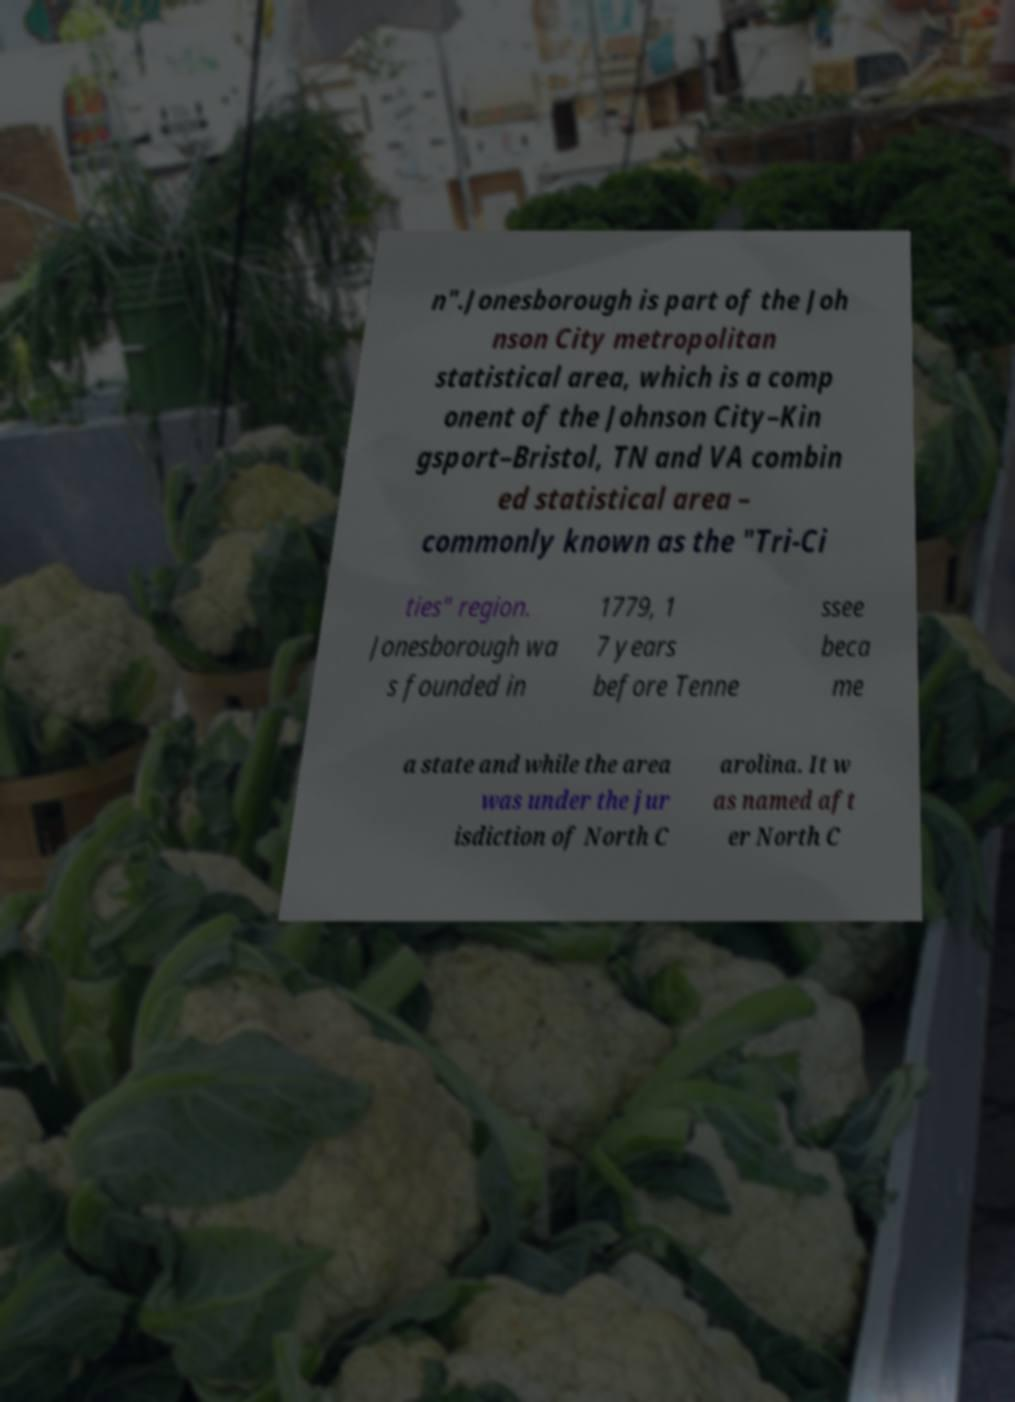I need the written content from this picture converted into text. Can you do that? n".Jonesborough is part of the Joh nson City metropolitan statistical area, which is a comp onent of the Johnson City–Kin gsport–Bristol, TN and VA combin ed statistical area – commonly known as the "Tri-Ci ties" region. Jonesborough wa s founded in 1779, 1 7 years before Tenne ssee beca me a state and while the area was under the jur isdiction of North C arolina. It w as named aft er North C 